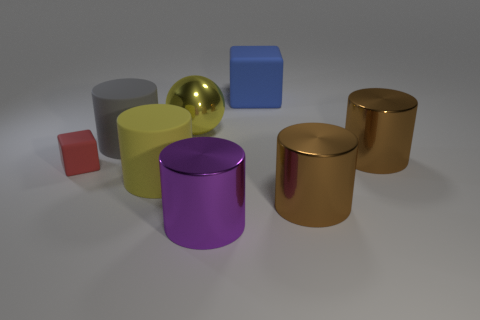Subtract 1 cylinders. How many cylinders are left? 4 Subtract all yellow matte cylinders. How many cylinders are left? 4 Subtract all yellow cylinders. How many cylinders are left? 4 Subtract all cyan balls. Subtract all cyan blocks. How many balls are left? 1 Add 2 large blue matte cubes. How many objects exist? 10 Subtract all cylinders. How many objects are left? 3 Subtract 0 blue spheres. How many objects are left? 8 Subtract all large gray matte objects. Subtract all large blue matte things. How many objects are left? 6 Add 4 yellow metal balls. How many yellow metal balls are left? 5 Add 7 yellow objects. How many yellow objects exist? 9 